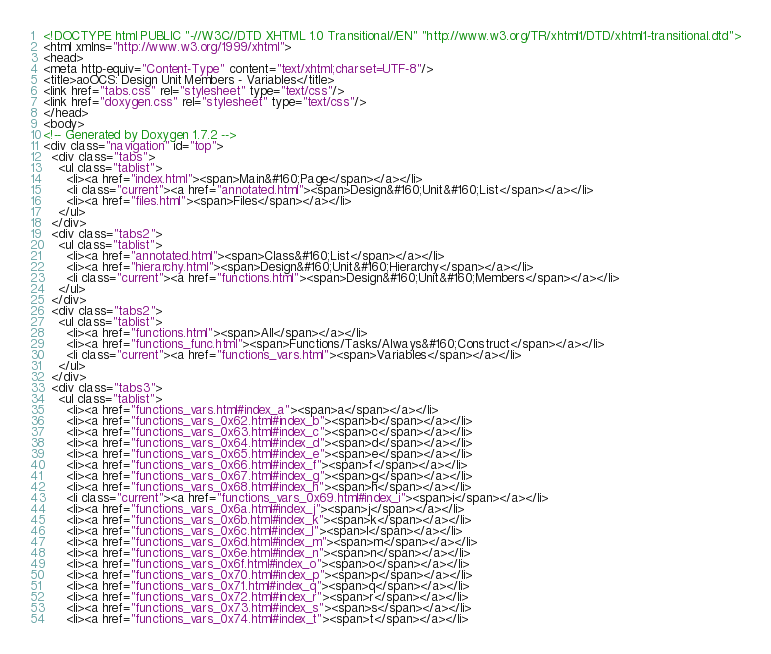Convert code to text. <code><loc_0><loc_0><loc_500><loc_500><_HTML_><!DOCTYPE html PUBLIC "-//W3C//DTD XHTML 1.0 Transitional//EN" "http://www.w3.org/TR/xhtml1/DTD/xhtml1-transitional.dtd">
<html xmlns="http://www.w3.org/1999/xhtml">
<head>
<meta http-equiv="Content-Type" content="text/xhtml;charset=UTF-8"/>
<title>aoOCS: Design Unit Members - Variables</title>
<link href="tabs.css" rel="stylesheet" type="text/css"/>
<link href="doxygen.css" rel="stylesheet" type="text/css"/>
</head>
<body>
<!-- Generated by Doxygen 1.7.2 -->
<div class="navigation" id="top">
  <div class="tabs">
    <ul class="tablist">
      <li><a href="index.html"><span>Main&#160;Page</span></a></li>
      <li class="current"><a href="annotated.html"><span>Design&#160;Unit&#160;List</span></a></li>
      <li><a href="files.html"><span>Files</span></a></li>
    </ul>
  </div>
  <div class="tabs2">
    <ul class="tablist">
      <li><a href="annotated.html"><span>Class&#160;List</span></a></li>
      <li><a href="hierarchy.html"><span>Design&#160;Unit&#160;Hierarchy</span></a></li>
      <li class="current"><a href="functions.html"><span>Design&#160;Unit&#160;Members</span></a></li>
    </ul>
  </div>
  <div class="tabs2">
    <ul class="tablist">
      <li><a href="functions.html"><span>All</span></a></li>
      <li><a href="functions_func.html"><span>Functions/Tasks/Always&#160;Construct</span></a></li>
      <li class="current"><a href="functions_vars.html"><span>Variables</span></a></li>
    </ul>
  </div>
  <div class="tabs3">
    <ul class="tablist">
      <li><a href="functions_vars.html#index_a"><span>a</span></a></li>
      <li><a href="functions_vars_0x62.html#index_b"><span>b</span></a></li>
      <li><a href="functions_vars_0x63.html#index_c"><span>c</span></a></li>
      <li><a href="functions_vars_0x64.html#index_d"><span>d</span></a></li>
      <li><a href="functions_vars_0x65.html#index_e"><span>e</span></a></li>
      <li><a href="functions_vars_0x66.html#index_f"><span>f</span></a></li>
      <li><a href="functions_vars_0x67.html#index_g"><span>g</span></a></li>
      <li><a href="functions_vars_0x68.html#index_h"><span>h</span></a></li>
      <li class="current"><a href="functions_vars_0x69.html#index_i"><span>i</span></a></li>
      <li><a href="functions_vars_0x6a.html#index_j"><span>j</span></a></li>
      <li><a href="functions_vars_0x6b.html#index_k"><span>k</span></a></li>
      <li><a href="functions_vars_0x6c.html#index_l"><span>l</span></a></li>
      <li><a href="functions_vars_0x6d.html#index_m"><span>m</span></a></li>
      <li><a href="functions_vars_0x6e.html#index_n"><span>n</span></a></li>
      <li><a href="functions_vars_0x6f.html#index_o"><span>o</span></a></li>
      <li><a href="functions_vars_0x70.html#index_p"><span>p</span></a></li>
      <li><a href="functions_vars_0x71.html#index_q"><span>q</span></a></li>
      <li><a href="functions_vars_0x72.html#index_r"><span>r</span></a></li>
      <li><a href="functions_vars_0x73.html#index_s"><span>s</span></a></li>
      <li><a href="functions_vars_0x74.html#index_t"><span>t</span></a></li></code> 